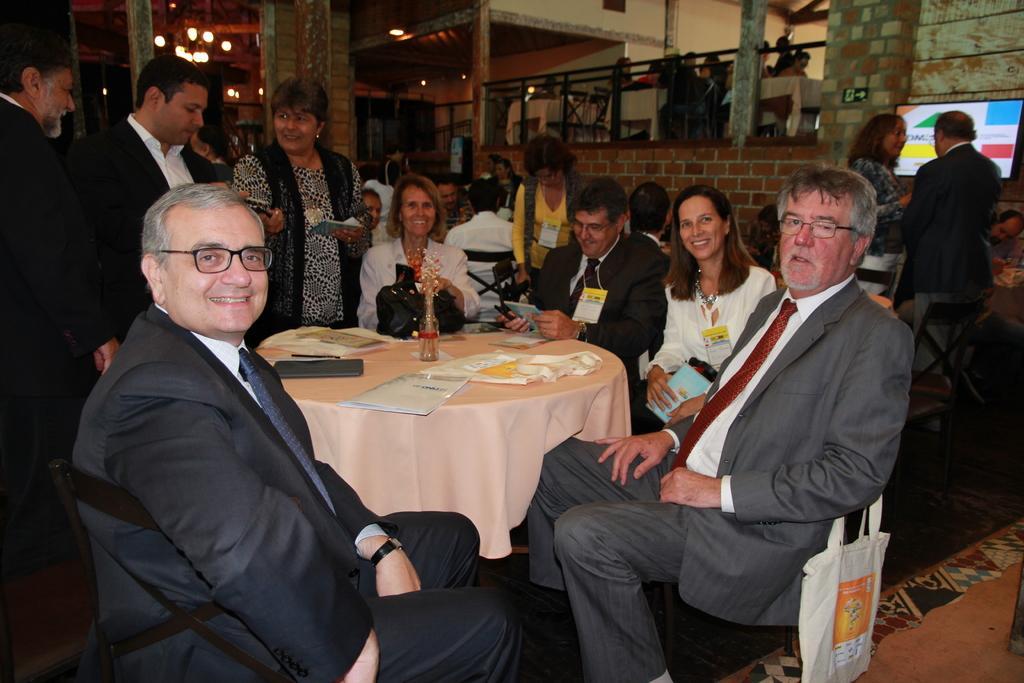How would you summarize this image in a sentence or two? As we can see in the image there is a brick wall, screen, few people here and there and there are chairs and tables. On table there are papers, tablet and flower flask. On the right side there is a cover. 